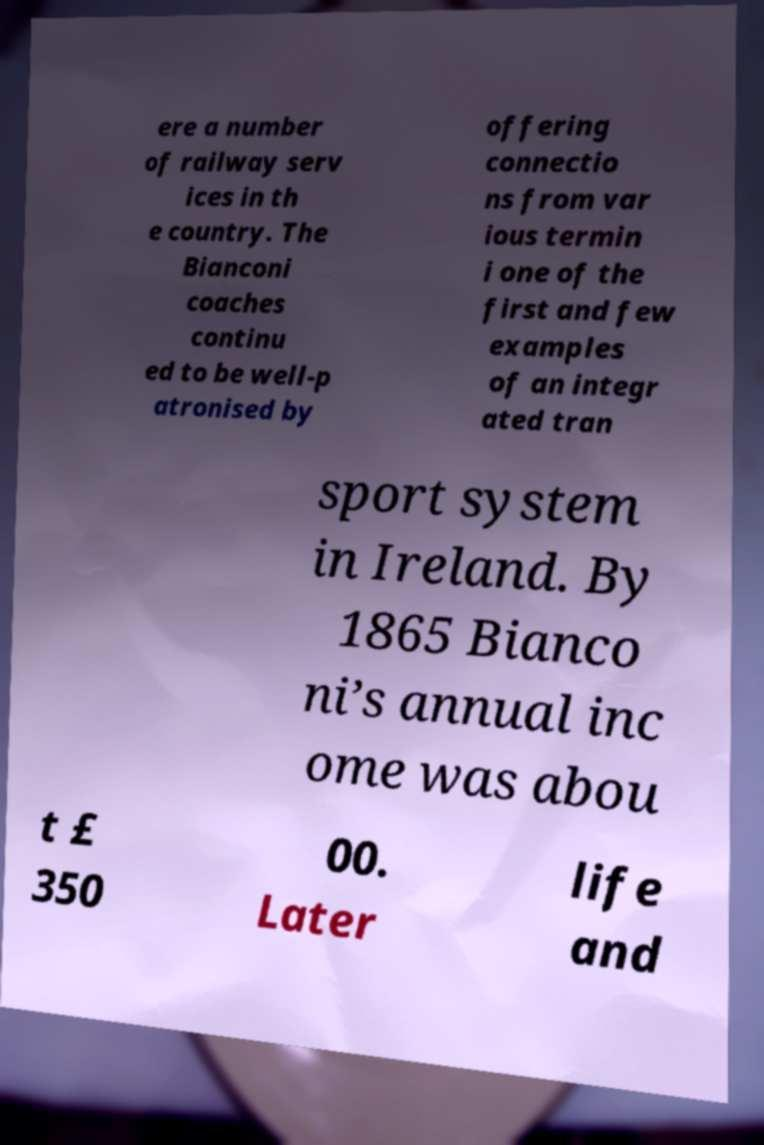For documentation purposes, I need the text within this image transcribed. Could you provide that? ere a number of railway serv ices in th e country. The Bianconi coaches continu ed to be well-p atronised by offering connectio ns from var ious termin i one of the first and few examples of an integr ated tran sport system in Ireland. By 1865 Bianco ni’s annual inc ome was abou t £ 350 00. Later life and 